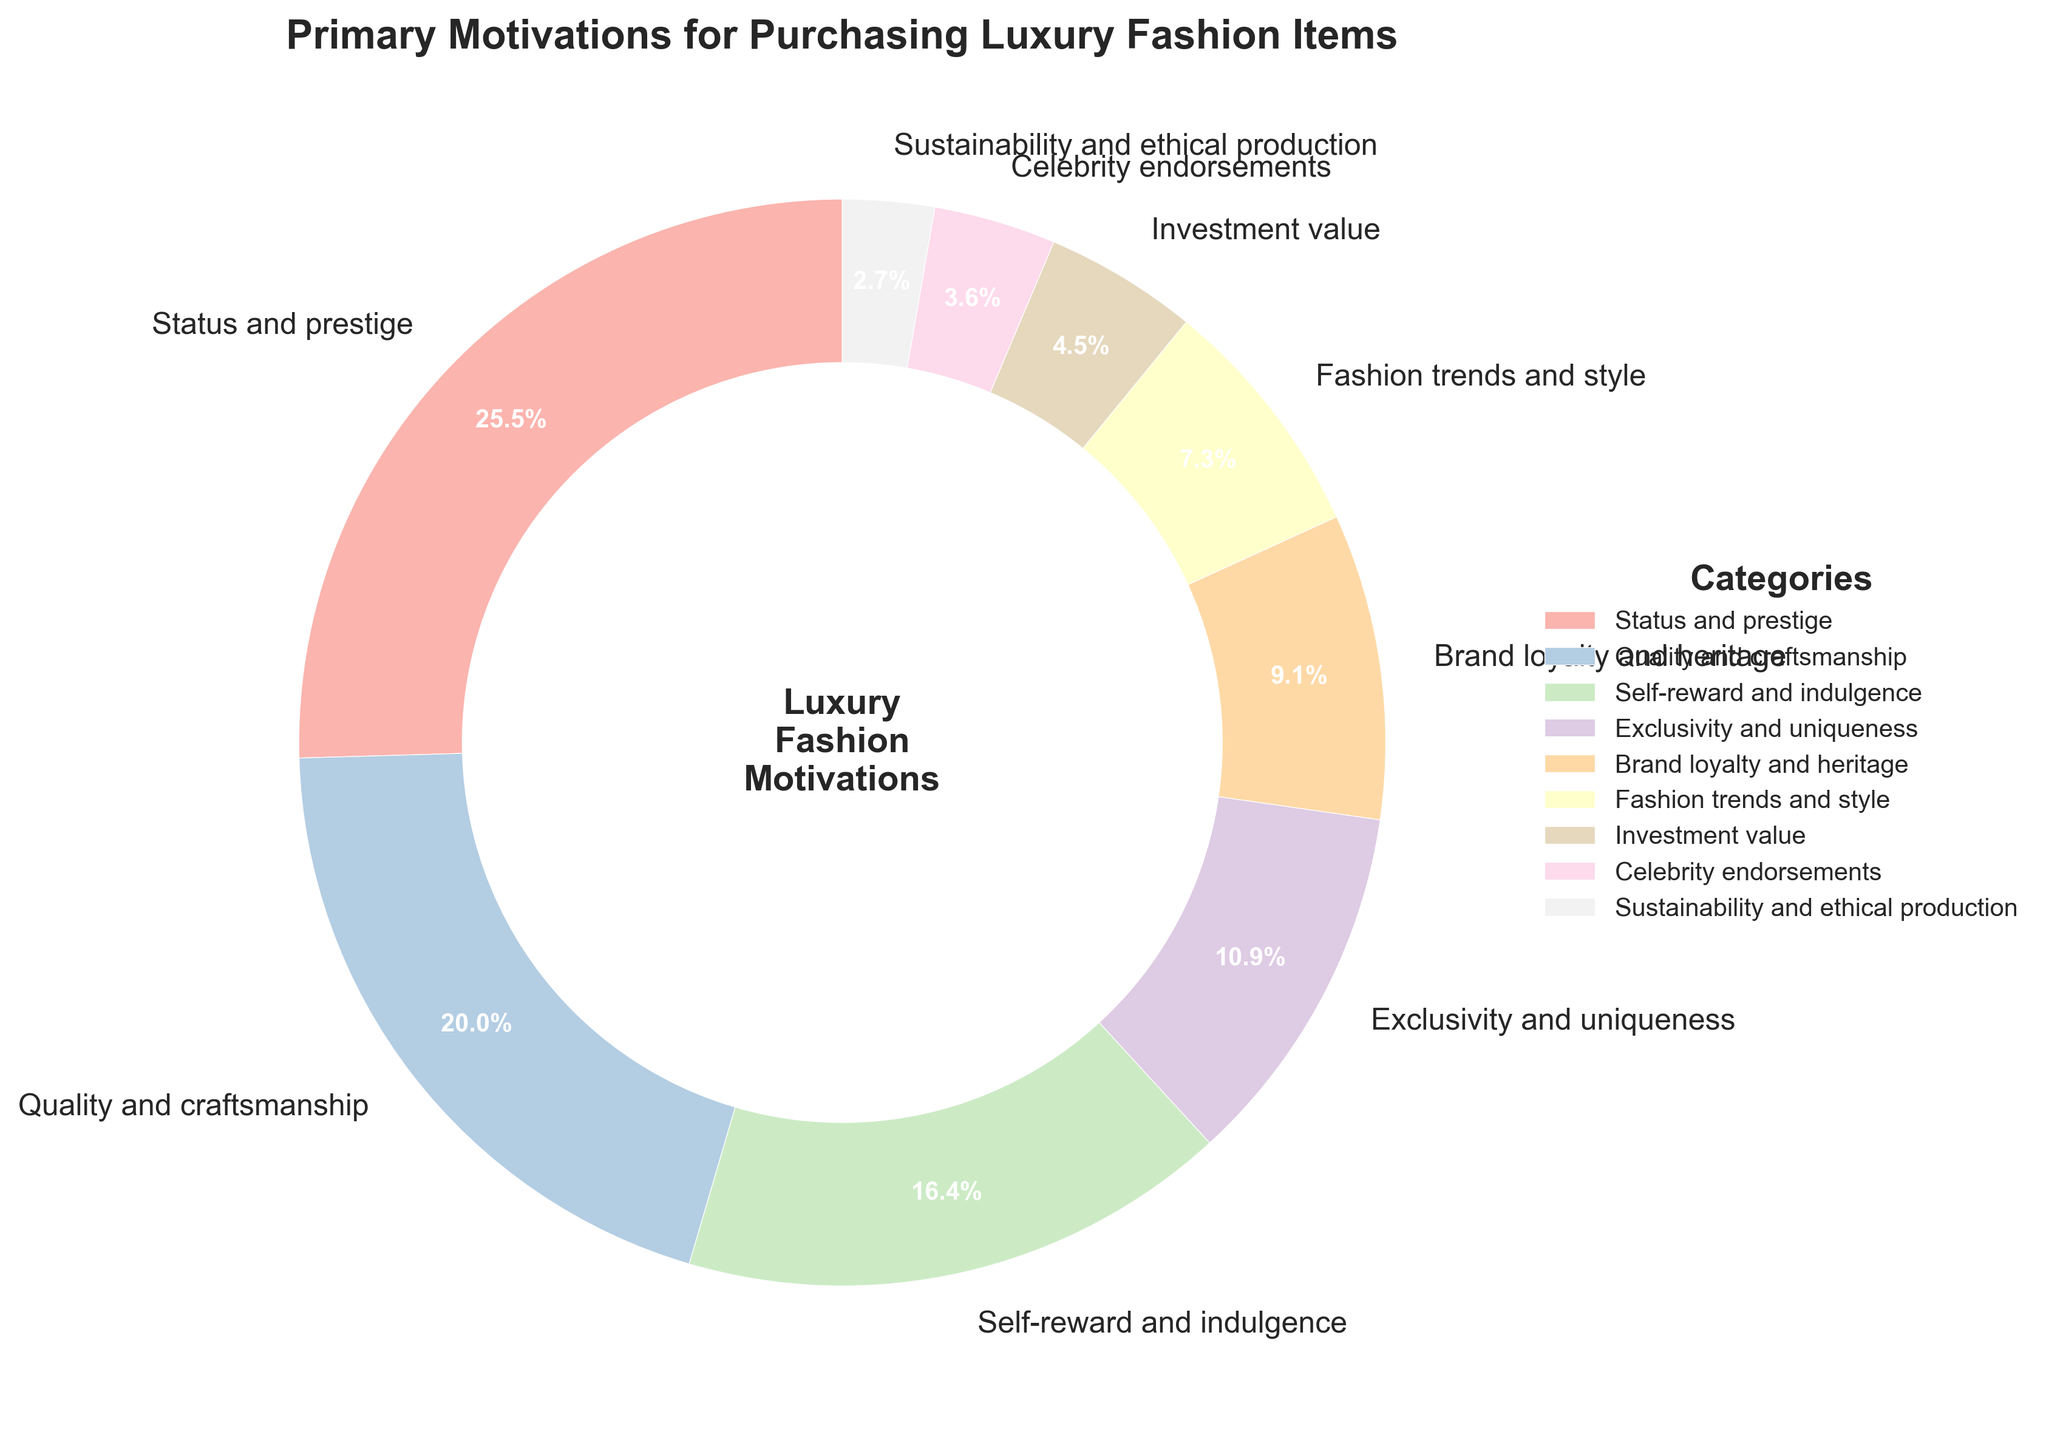What category has the highest percentage in the pie chart? The category with the highest percentage can be identified by looking for the largest slice of the pie, which is often labeled with percentages. The largest slice belongs to "Status and prestige" with 28%.
Answer: Status and prestige Which categories combined make up more than half of the total motivations? We need to sum the percentages for different categories and see when the sum exceeds 50%. Starting with the largest segments: Status and prestige (28%) + Quality and craftsmanship (22%) = 50%, so these two alone reach exactly 50%. Therefore, these two categories together make up exactly half.
Answer: Status and prestige and Quality and craftsmanship What is the difference in percentage between the top motivation and the least motivation? First, identify the top motivation (Status and prestige with 28%) and the least motivation (Sustainability and ethical production with 3%). Then, calculate the difference: 28% - 3% = 25%.
Answer: 25% Among the categories, which one stands out for having around one-fifth of the total percentage? One-fifth of the total percentage is 20%. The category closest to this value is Quality and craftsmanship with 22%.
Answer: Quality and craftsmanship Which is the smallest category, and what percentage does it represent? The smallest slice of the pie chart represents the smallest category. This is "Sustainability and ethical production" with 3%.
Answer: Sustainability and ethical production If we group "Status and prestige" and "Quality and craftsmanship" together, what percentage do they collectively represent? To find the combined percentage, add the values for "Status and prestige" (28%) and "Quality and craftsmanship" (22%): 28% + 22% = 50%.
Answer: 50% Compare the percentages of "Self-reward and indulgence" and "Brand loyalty and heritage". Which one is higher and by how much? First, look at their individual percentages: "Self-reward and indulgence" is 18% and "Brand loyalty and heritage" is 10%. The difference is 18% - 10% = 8%.
Answer: Self-reward and indulgence by 8% Which categories have less than 10%? Identify slices with percentages less than 10%. These are: Fashion trends and style (8%), Investment value (5%), Celebrity endorsements (4%), and Sustainability and ethical production (3%).
Answer: Fashion trends and style, Investment value, Celebrity endorsements, Sustainability and ethical production What percentage do the bottom three categories together represent? Sum the percentages of the three smallest categories: Investment value (5%), Celebrity endorsements (4%), and Sustainability and ethical production (3%). The combined percentage is 5% + 4% + 3% = 12%.
Answer: 12% How much larger is the "Status and prestige" category compared to the "Fashion trends and style" category? Calculate the difference in their percentages: "Status and prestige" (28%) - "Fashion trends and style" (8%) = 20%.
Answer: 20% 